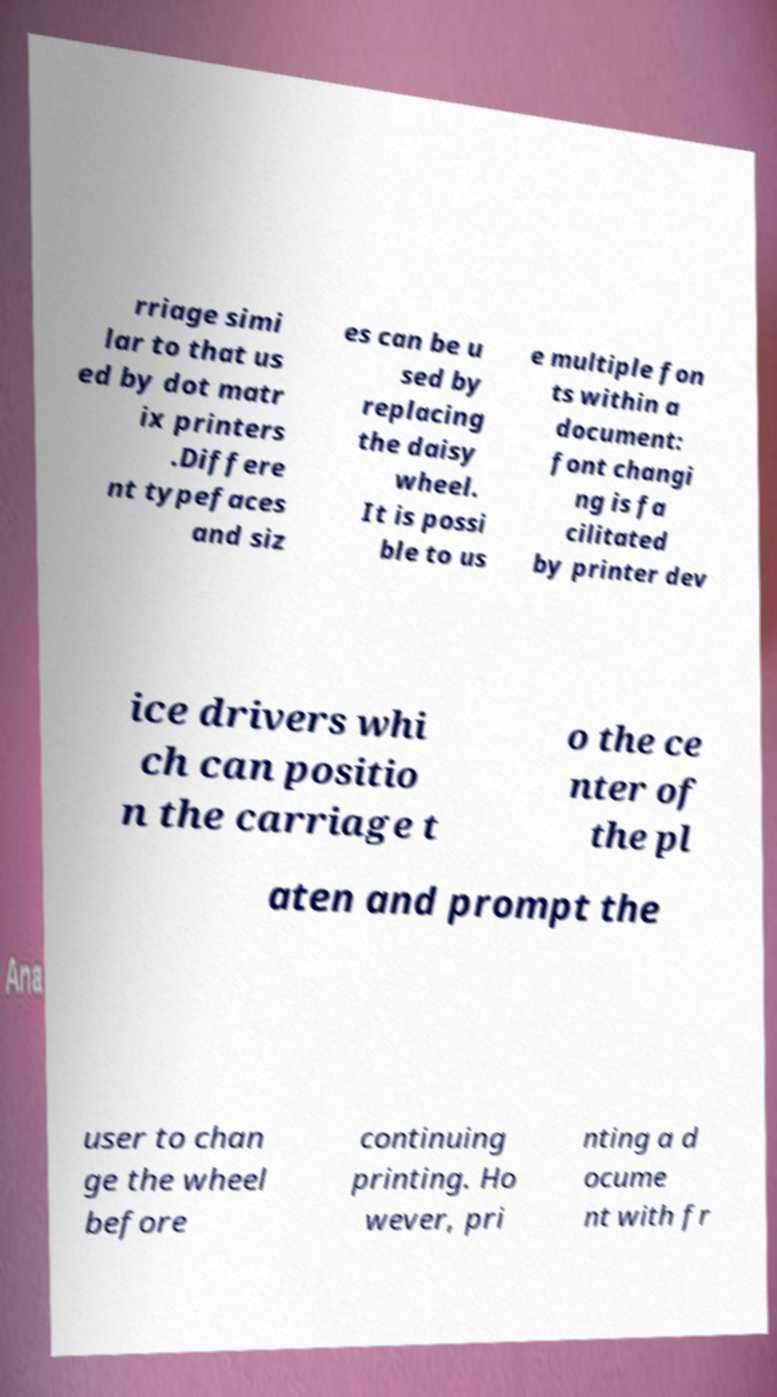Please identify and transcribe the text found in this image. rriage simi lar to that us ed by dot matr ix printers .Differe nt typefaces and siz es can be u sed by replacing the daisy wheel. It is possi ble to us e multiple fon ts within a document: font changi ng is fa cilitated by printer dev ice drivers whi ch can positio n the carriage t o the ce nter of the pl aten and prompt the user to chan ge the wheel before continuing printing. Ho wever, pri nting a d ocume nt with fr 